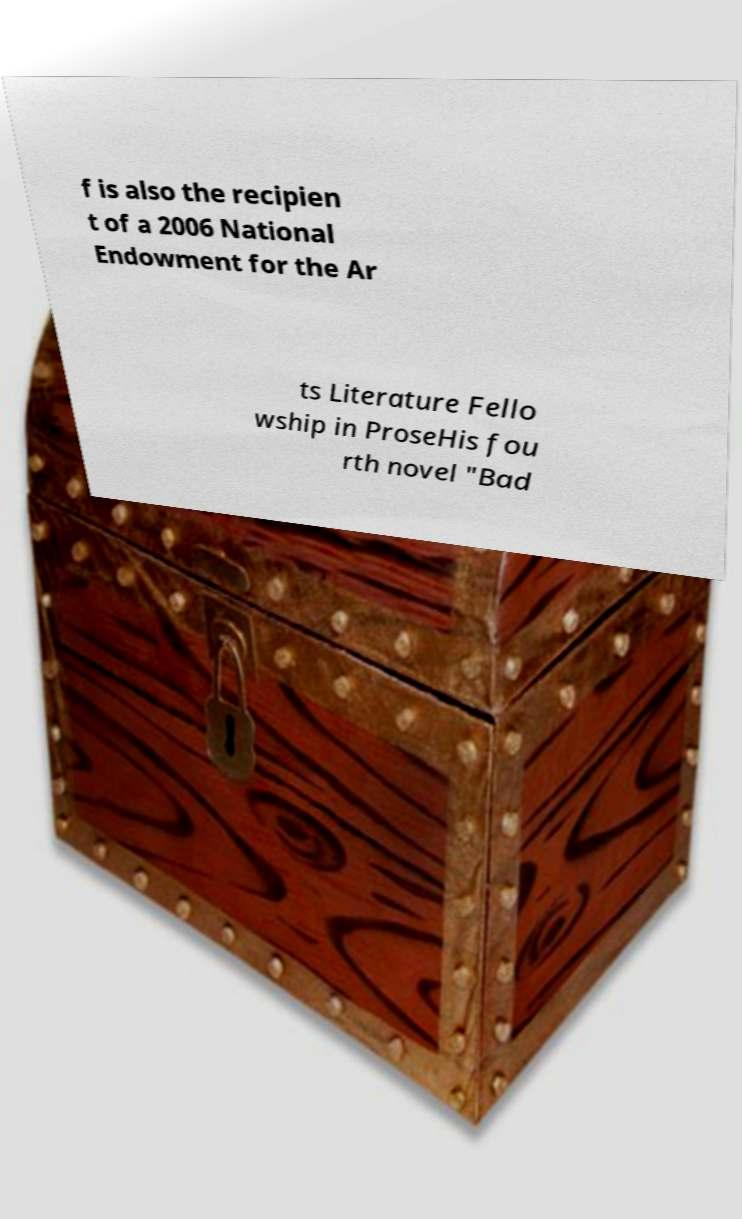Could you extract and type out the text from this image? f is also the recipien t of a 2006 National Endowment for the Ar ts Literature Fello wship in ProseHis fou rth novel "Bad 